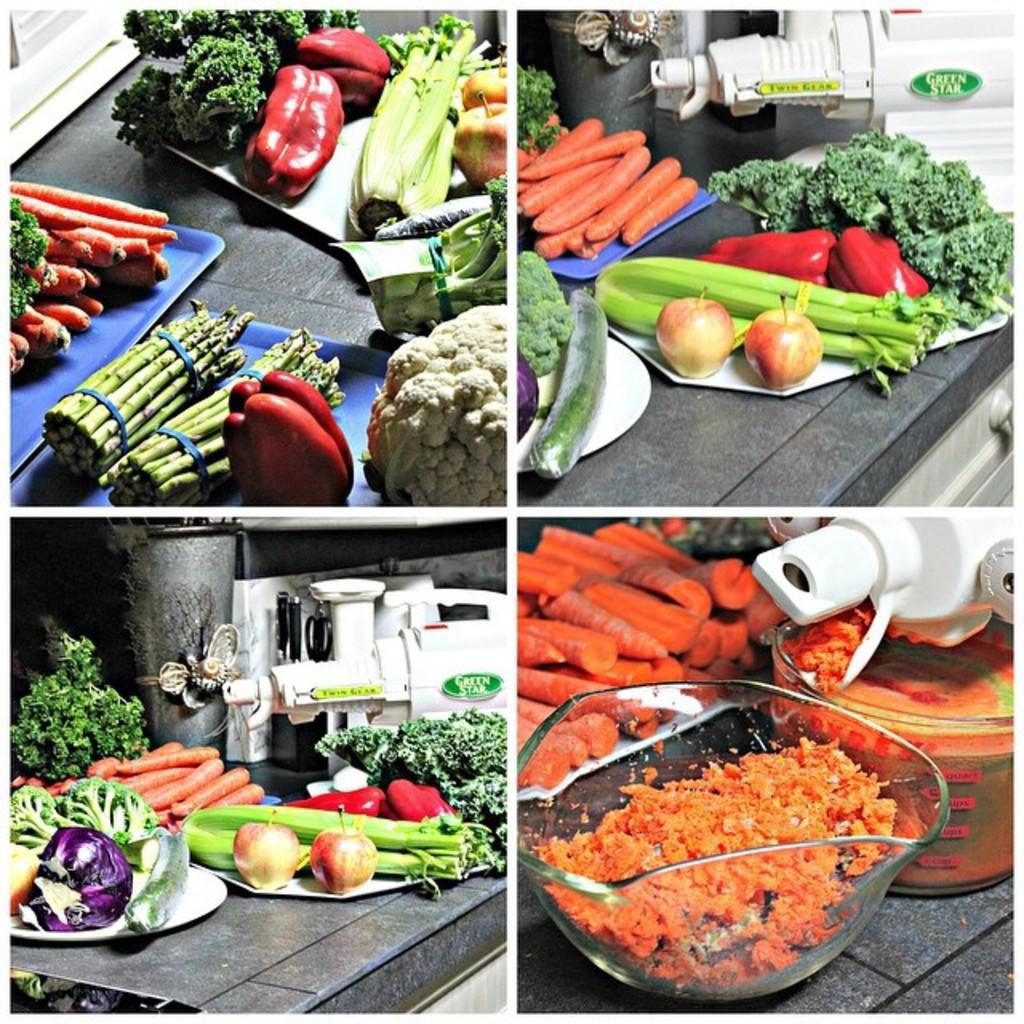In one or two sentences, can you explain what this image depicts? In this image we can see a collage of four pictures. In first image vegetables are there. In the second, third and forth image one white color machine is present with vegetables and fruits. 